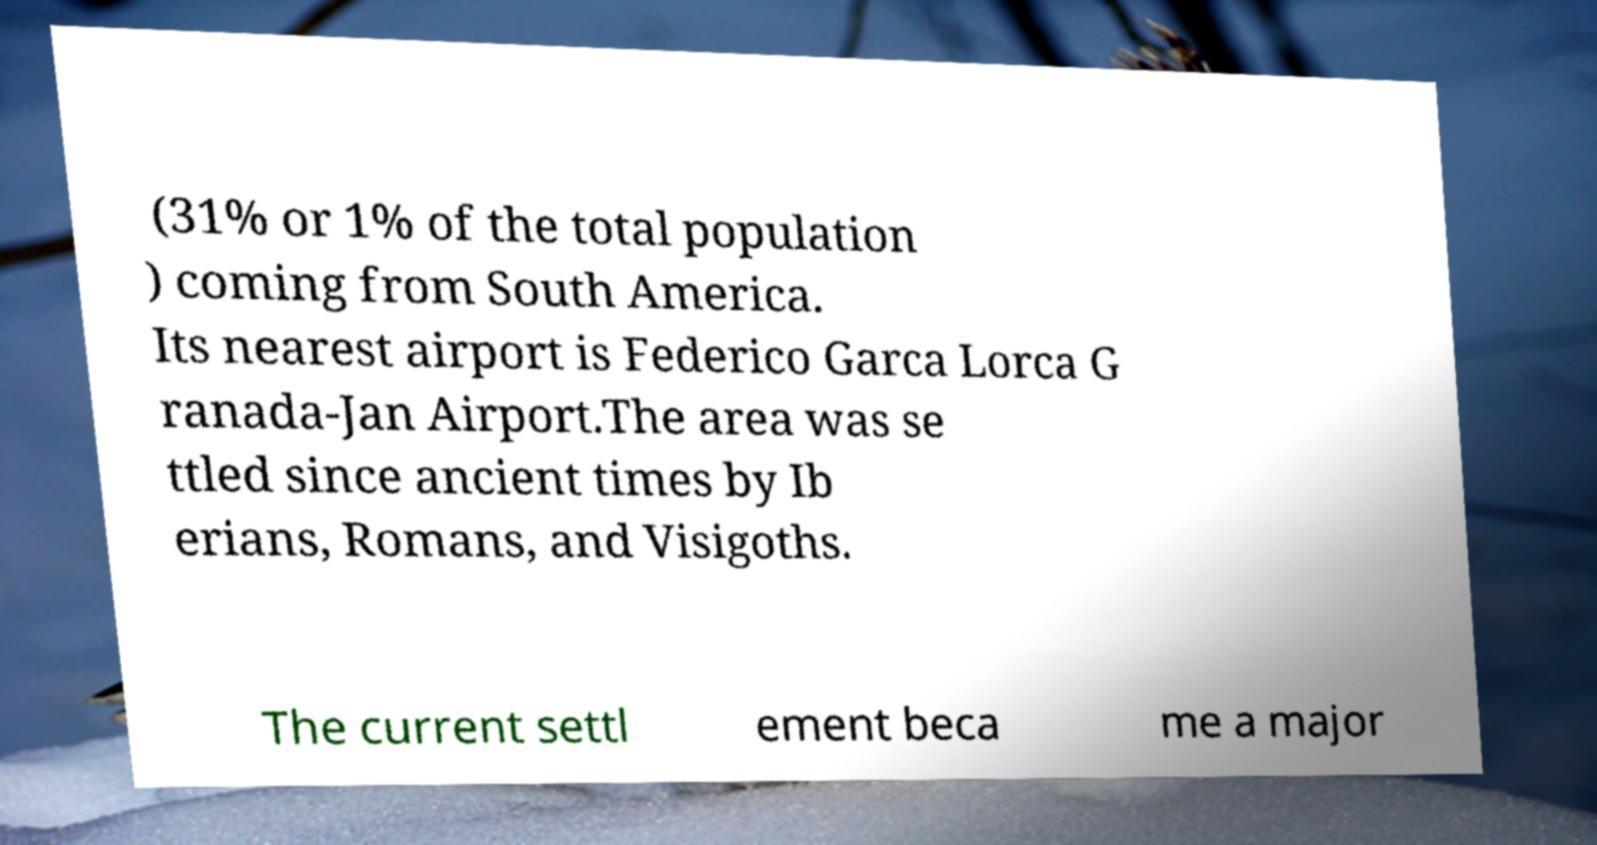For documentation purposes, I need the text within this image transcribed. Could you provide that? (31% or 1% of the total population ) coming from South America. Its nearest airport is Federico Garca Lorca G ranada-Jan Airport.The area was se ttled since ancient times by Ib erians, Romans, and Visigoths. The current settl ement beca me a major 